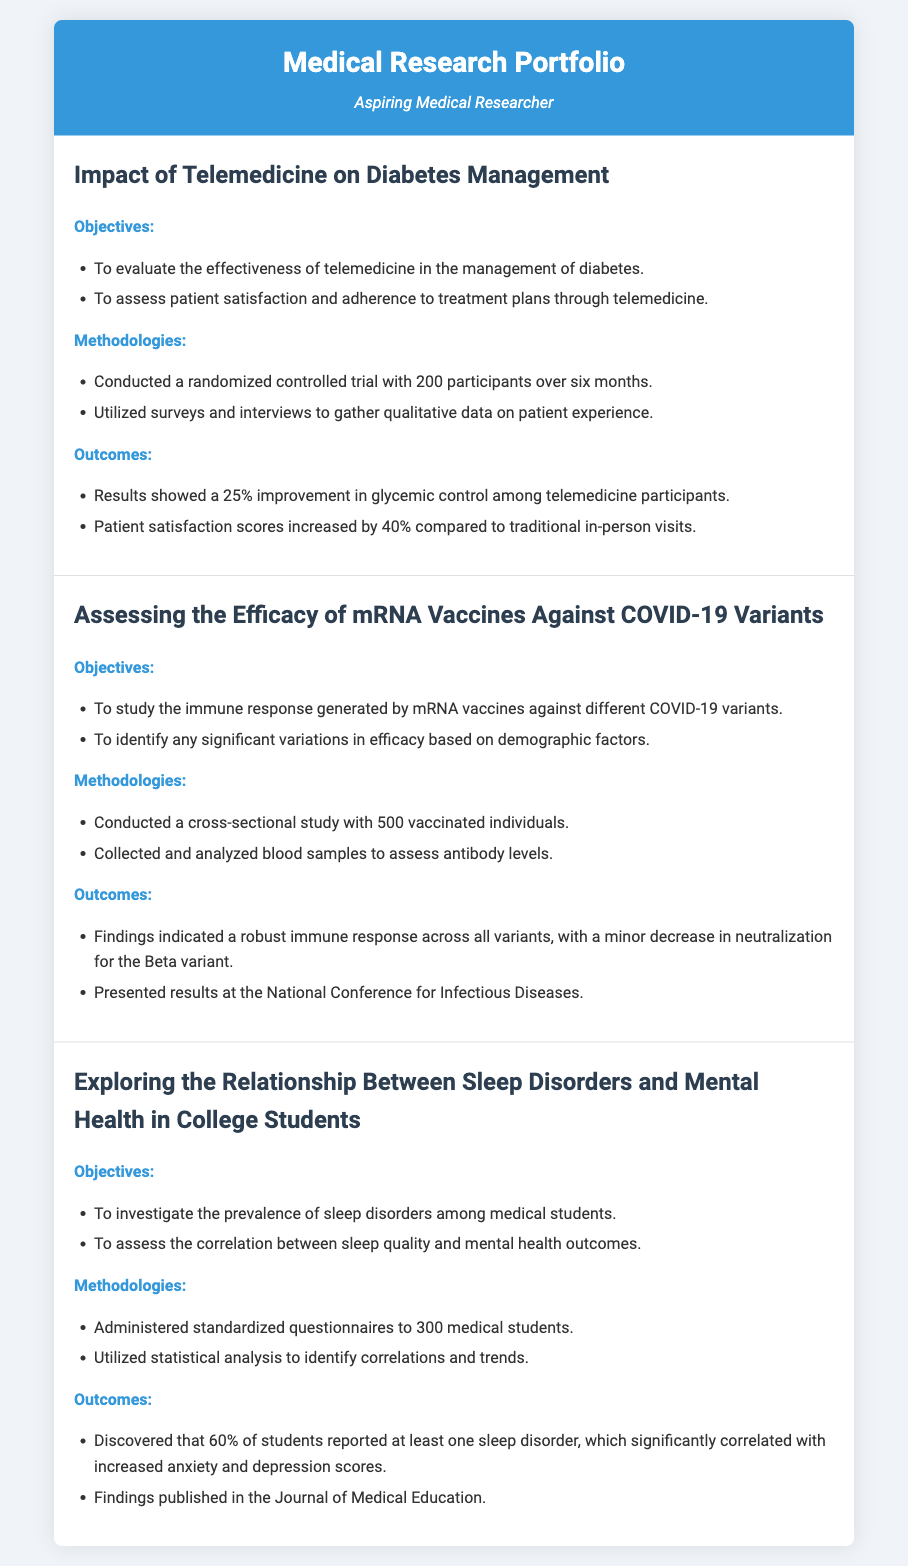what is the title of the first research project? The title of the first research project is stated at the beginning of the project section.
Answer: Impact of Telemedicine on Diabetes Management how many participants were involved in the randomized controlled trial? The number of participants is explicitly mentioned in the methodology section of the first project.
Answer: 200 what was the percentage increase in patient satisfaction scores? This figure can be found in the outcomes section of the first project, describing the results.
Answer: 40% how many individuals were studied in the mRNA vaccine project? The total number of individuals is indicated in the methodologies of the second project.
Answer: 500 what is the prevalence of sleep disorders reported by medical students? This statistic is provided in the outcomes section of the third project.
Answer: 60% which variant showed a minor decrease in neutralization? The specific variant is mentioned in the outcomes section of the second project regarding efficacy of mRNA vaccines.
Answer: Beta which journal published the findings on sleep disorders and mental health? The name of the journal is indicated in the outcomes of the third project.
Answer: Journal of Medical Education how long was the trial conducted for the telemedicine project? The duration of the trial is detailed in the methodologies section of the first project.
Answer: Six months 